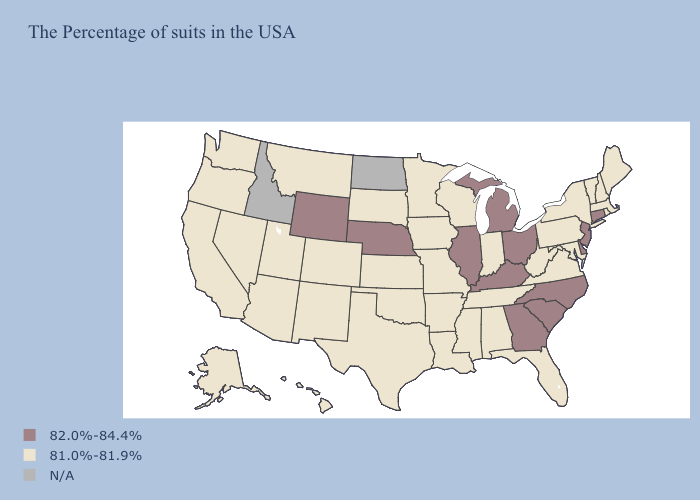Name the states that have a value in the range N/A?
Write a very short answer. North Dakota, Idaho. Does Ohio have the highest value in the USA?
Quick response, please. Yes. What is the value of Minnesota?
Concise answer only. 81.0%-81.9%. Does South Carolina have the highest value in the South?
Be succinct. Yes. What is the highest value in the USA?
Be succinct. 82.0%-84.4%. Which states have the lowest value in the West?
Quick response, please. Colorado, New Mexico, Utah, Montana, Arizona, Nevada, California, Washington, Oregon, Alaska, Hawaii. What is the lowest value in the USA?
Give a very brief answer. 81.0%-81.9%. What is the value of Kansas?
Write a very short answer. 81.0%-81.9%. Name the states that have a value in the range N/A?
Be succinct. North Dakota, Idaho. Is the legend a continuous bar?
Concise answer only. No. What is the value of Minnesota?
Write a very short answer. 81.0%-81.9%. Among the states that border Tennessee , which have the lowest value?
Short answer required. Virginia, Alabama, Mississippi, Missouri, Arkansas. 